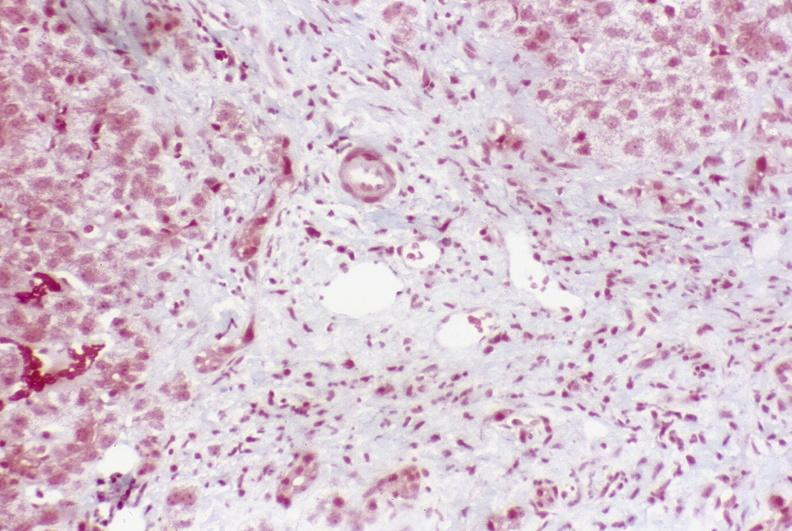s cardiovascular present?
Answer the question using a single word or phrase. No 